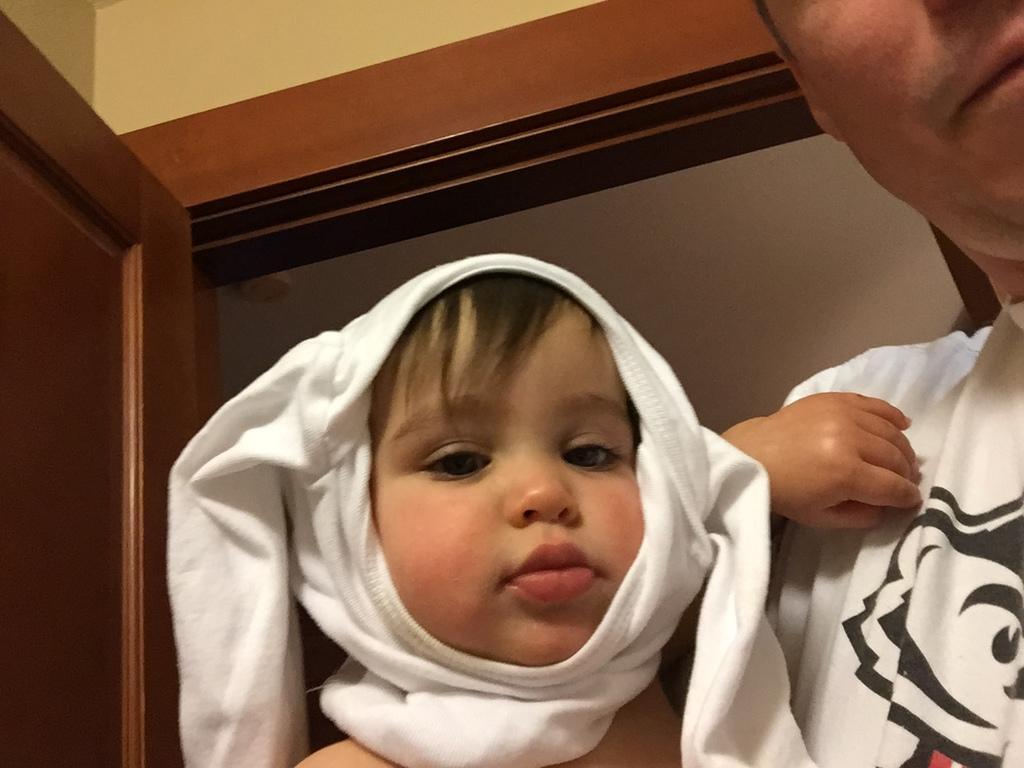Please provide a concise description of this image. In this image we can see few people. There is a door at the left side of the image. There is an object in the image. 